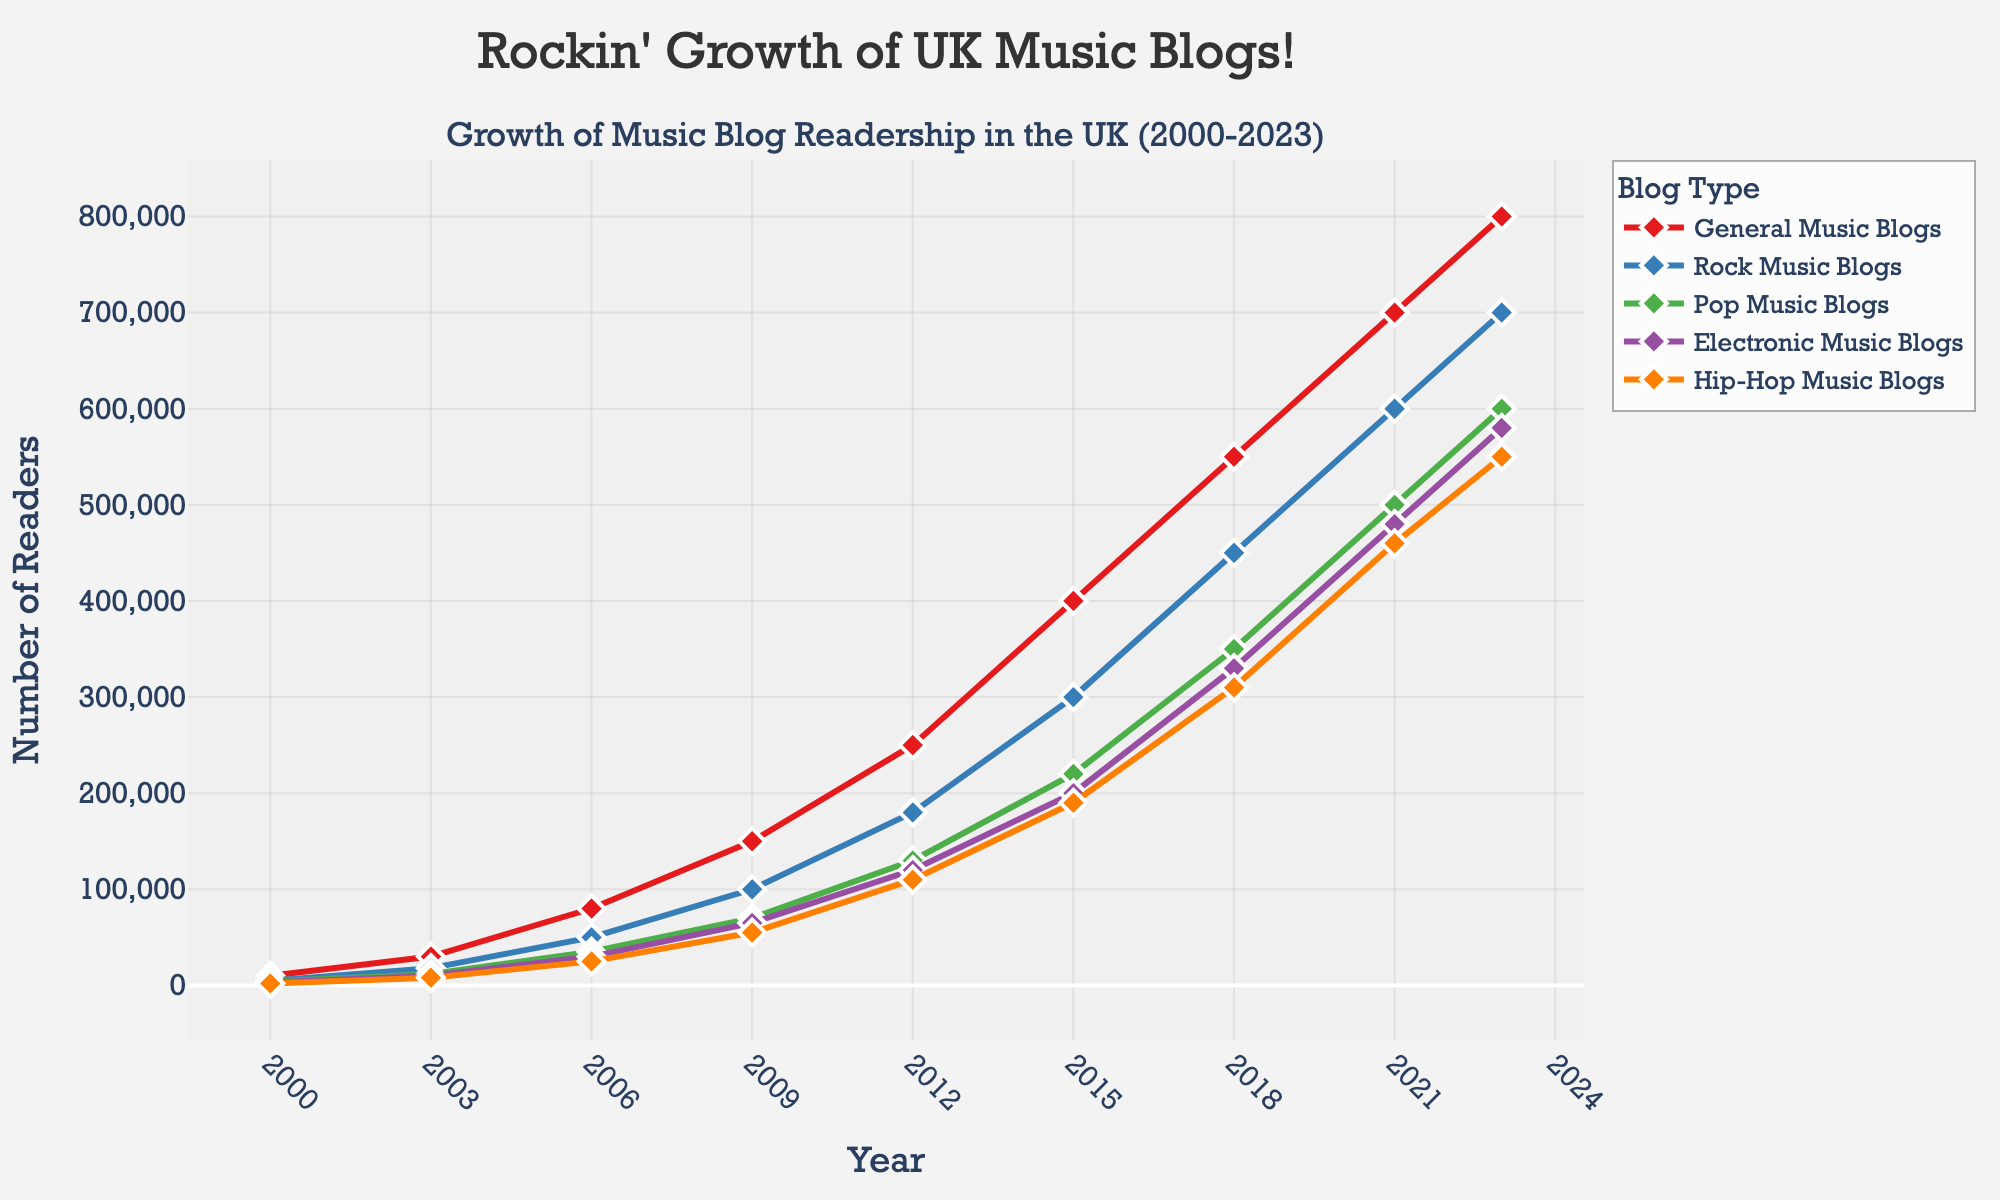**Q1:** Which type of music blog had the highest readership in 2009? The graph shows several music blog types in different colors and tracks their readership over the years. For 2009, find the highest point among them. The Rock Music Blogs peaked highest among all blog types for this year.
Answer: Rock Music Blogs **Q2:** What is the percentage growth in readership for General Music Blogs from 2000 to 2023? To find the percentage growth, use the formula: ((readership in 2023 - readership in 2000) / readership in 2000) * 100. The values are 800000 (2023) and 10000 (2000). So, ((800000 - 10000) / 10000) * 100 = 7900%.
Answer: 7900% **Q3:** On average, how many readers did Pop Music Blogs have in the years shown in the graph? Add the readership numbers for Pop Music Blogs across all years and divide by the count of years. That is (4000 + 12000 + 35000 + 70000 + 130000 + 220000 + 350000 + 500000 + 600000) / 9 = 2140000 / 9 ≈ 237778.
Answer: 237778 **Q4:** In which year did Hip-Hop Music Blogs and Electronic Music Blogs have an equal number of readers? Look at the intersections of the Hip-Hop Music Blogs and Electronic Music Blogs lines. They intersect at 2021.
Answer: 2021 **Q5:** Which blog type shows the most consistent growth trend over the years? Visually, the blog type with the smoothest upward trajectory is the one with the most consistent growth. Rock Music Blogs show a steady increment without significant dips.
Answer: Rock Music Blogs **Q6:** How much more readership did Rock Music Blogs have compared to Electronic Music Blogs in 2023? Subtract the readership of Electronic Music Blogs from that of Rock Music Blogs for the year 2023. The values are 700000 (Rock) and 580000 (Electronic). So, 700000 - 580000 = 120000.
Answer: 120000 **Q7:** Did the readership for any blog type decline between two consecutive data points at any time? To determine a decline, look for downward trends in each blog type line. None of the lines show a downward trend between any two data points.
Answer: No **Q8:** How does the growth from 2015 to 2018 of General Music Blogs compare to the growth from 2018 to 2021? Calculate the growth(2015-2018) and growth(2018-2021) using the formula: (readership in end year - readership in start year). Growth(2015-2018): 550000 - 400000 = 150000. Growth(2018-2021): 700000 - 550000 = 150000. Both growth periods show an increase of 150000 readers.
Answer: Equal **Q9:** What is the color assigned to Hip-Hop Music Blogs in the graph? The color set for Hip-Hop Music Blogs corresponds to the orange line in the graph.
Answer: Orange 